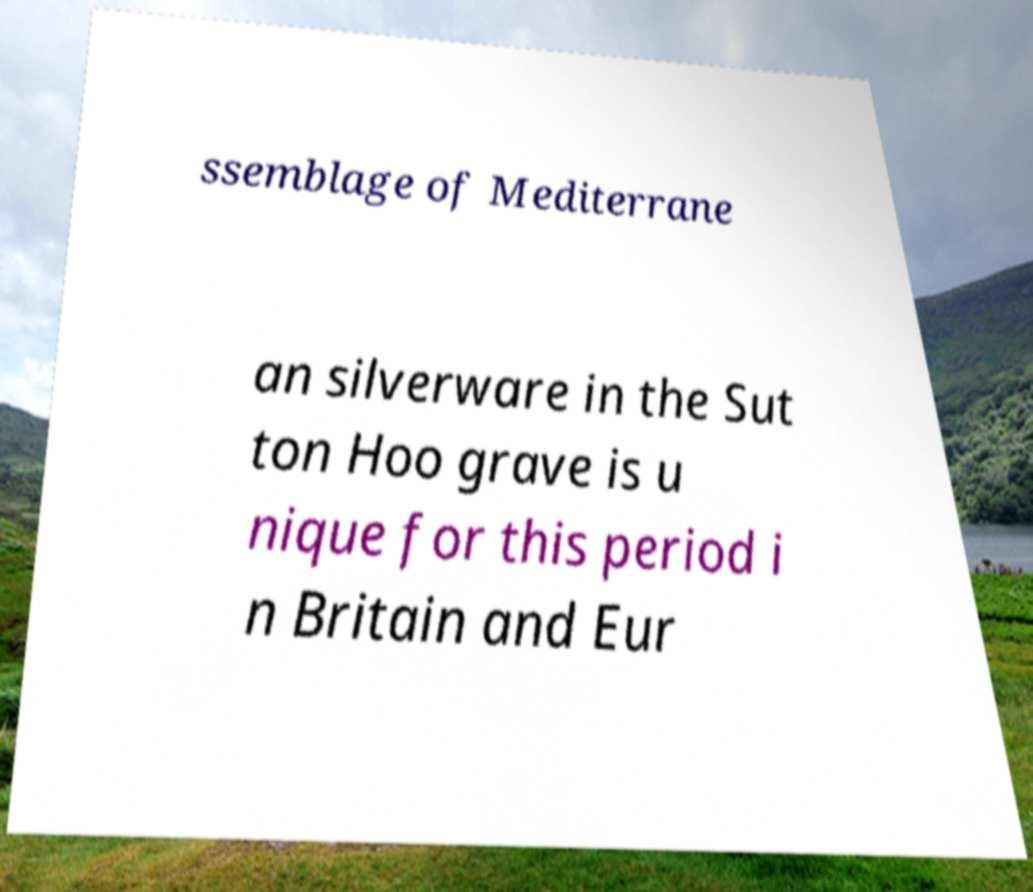Can you read and provide the text displayed in the image?This photo seems to have some interesting text. Can you extract and type it out for me? ssemblage of Mediterrane an silverware in the Sut ton Hoo grave is u nique for this period i n Britain and Eur 